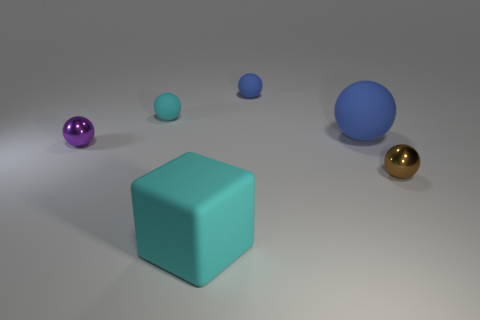Subtract all cyan rubber balls. How many balls are left? 4 Subtract 5 balls. How many balls are left? 0 Add 1 blue rubber balls. How many objects exist? 7 Subtract all blocks. How many objects are left? 5 Subtract all cyan balls. How many balls are left? 4 Subtract all yellow spheres. How many blue cubes are left? 0 Subtract all cyan things. Subtract all blue rubber objects. How many objects are left? 2 Add 4 big blue matte balls. How many big blue matte balls are left? 5 Add 4 purple metal objects. How many purple metal objects exist? 5 Subtract 0 brown cylinders. How many objects are left? 6 